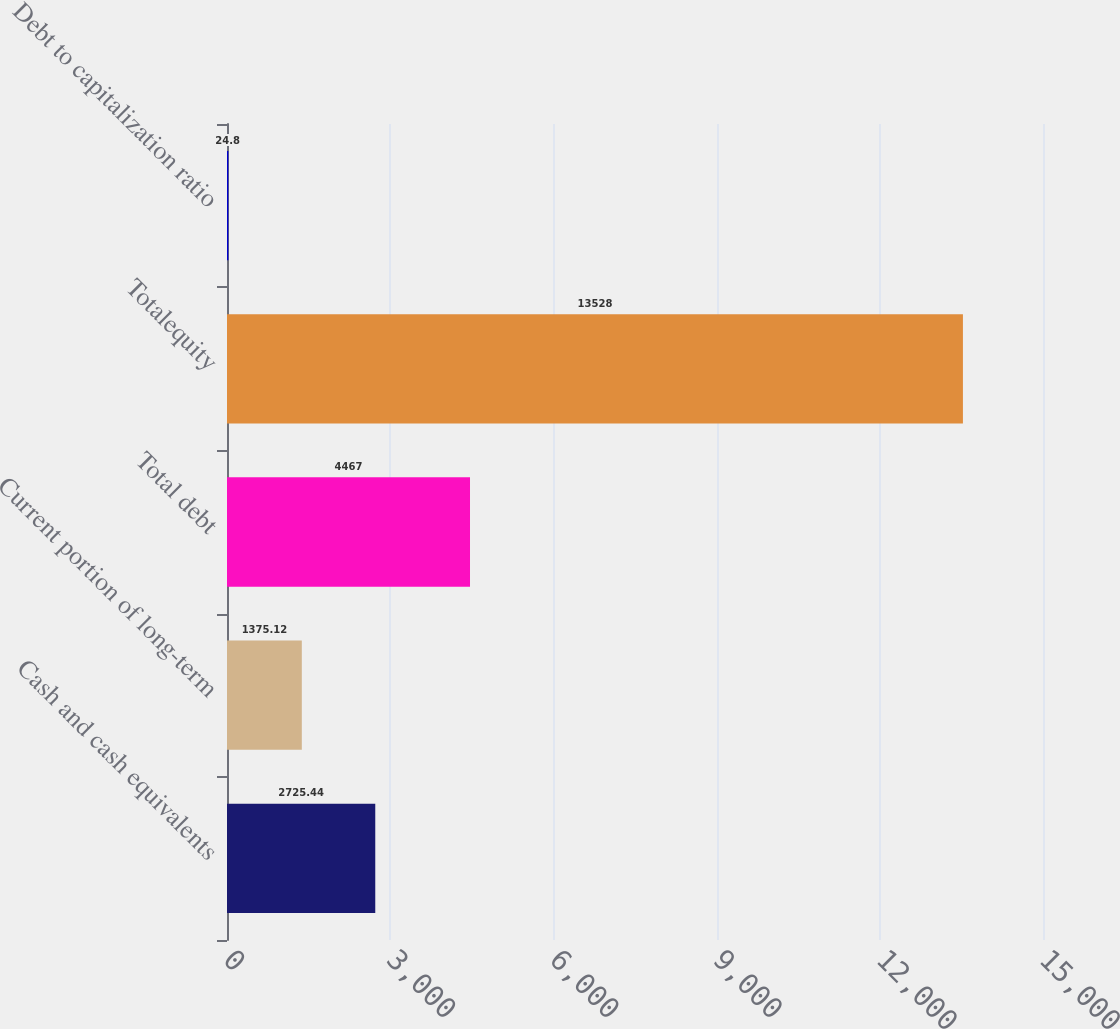<chart> <loc_0><loc_0><loc_500><loc_500><bar_chart><fcel>Cash and cash equivalents<fcel>Current portion of long-term<fcel>Total debt<fcel>Totalequity<fcel>Debt to capitalization ratio<nl><fcel>2725.44<fcel>1375.12<fcel>4467<fcel>13528<fcel>24.8<nl></chart> 